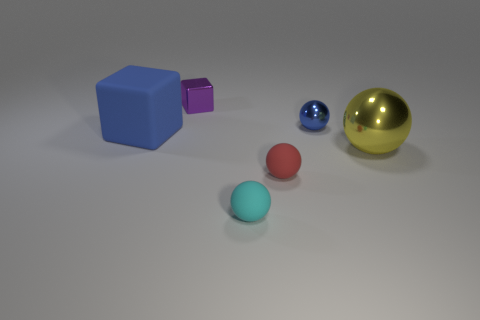There is a blue object that is to the left of the purple metal block that is on the right side of the blue rubber object; are there any tiny rubber objects left of it?
Ensure brevity in your answer.  No. Are there any other things that have the same color as the big block?
Keep it short and to the point. Yes. There is a cyan object that is in front of the purple cube; what size is it?
Give a very brief answer. Small. There is a blue thing to the right of the blue object that is on the left side of the shiny ball behind the yellow metal ball; how big is it?
Your response must be concise. Small. The cube behind the large object that is on the left side of the small cyan thing is what color?
Your response must be concise. Purple. There is a cyan object that is the same shape as the small red object; what material is it?
Provide a succinct answer. Rubber. Are there any small balls to the right of the tiny purple metal thing?
Give a very brief answer. Yes. How many large objects are there?
Make the answer very short. 2. There is a metal thing that is left of the cyan sphere; how many blue cubes are on the left side of it?
Your answer should be very brief. 1. Is the color of the big rubber thing the same as the small ball behind the big cube?
Provide a succinct answer. Yes. 